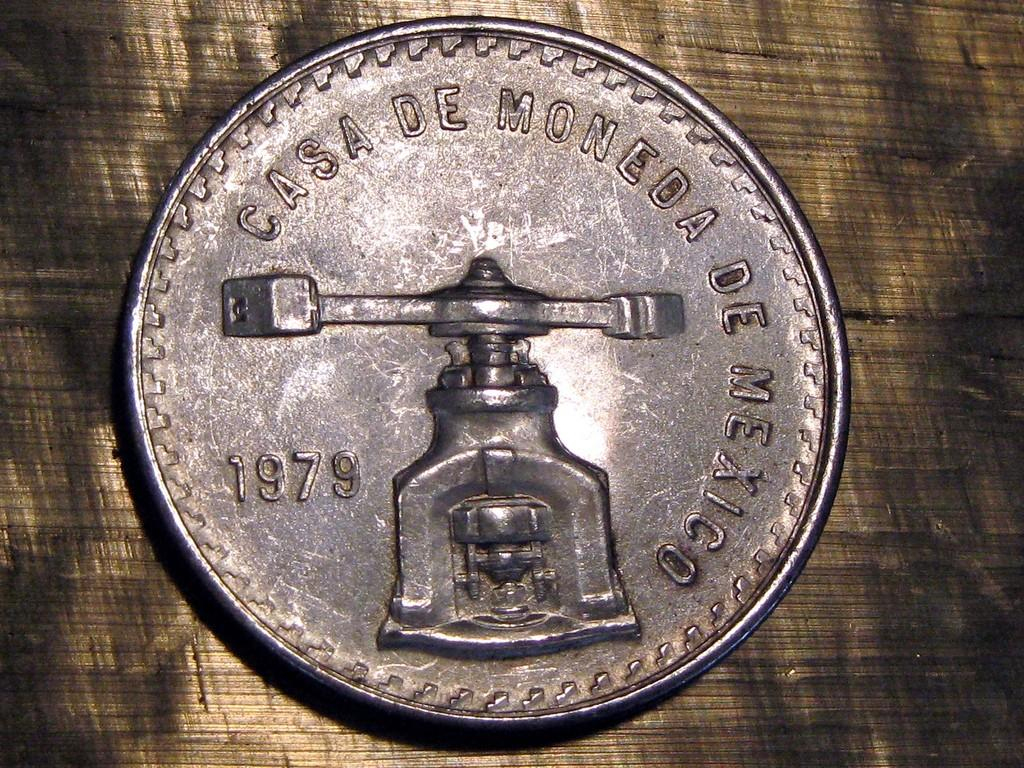<image>
Offer a succinct explanation of the picture presented. A silver coin about the size of a quarter 